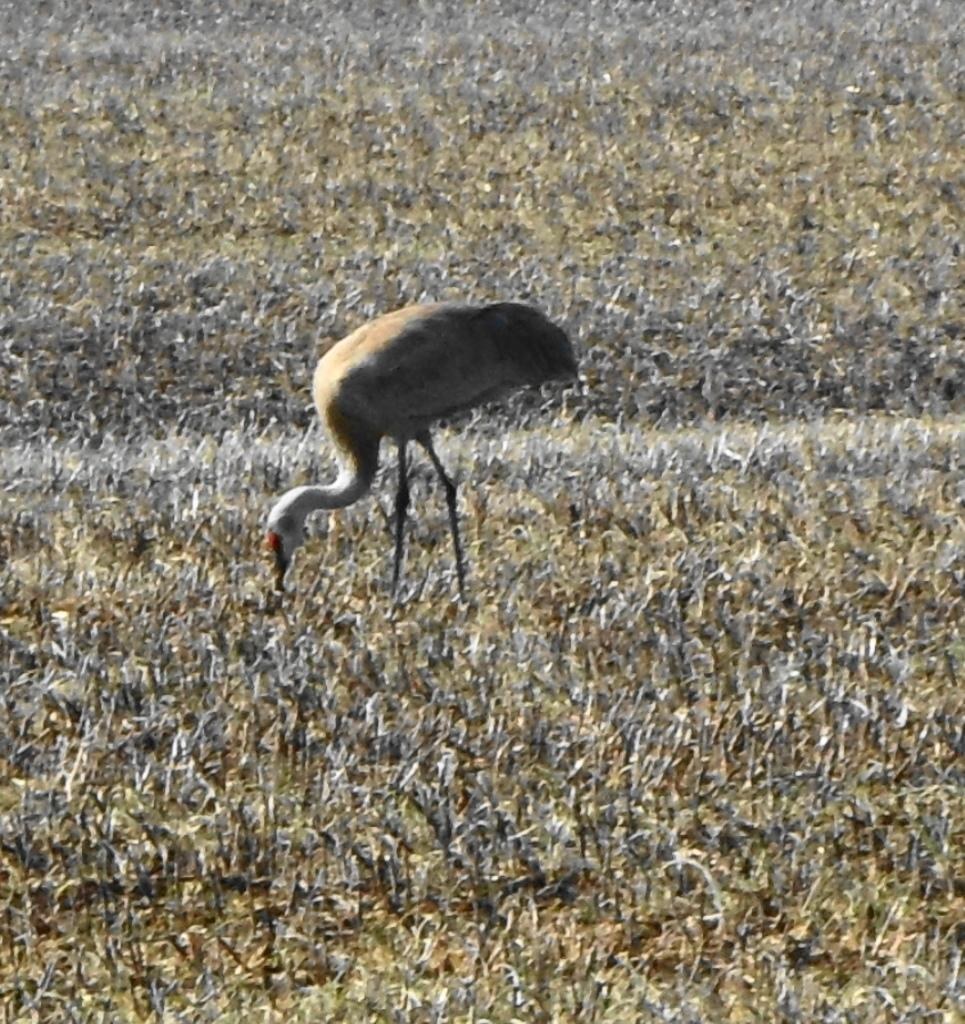What is the main subject of the picture? The main subject of the picture is a bird. Where is the bird located in the image? The bird is in a field. What else can be seen in the image besides the bird? There are plants in the image. What type of mask is the bird wearing in the image? There is no mask present on the bird in the image. What vegetables can be seen growing in the field with the bird? There are no vegetables visible in the image; only plants are present. 